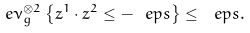Convert formula to latex. <formula><loc_0><loc_0><loc_500><loc_500>\ e \nu _ { g } ^ { \otimes 2 } \left \{ z ^ { 1 } \cdot z ^ { 2 } \leq - \ e p s \right \} \leq \ e p s .</formula> 